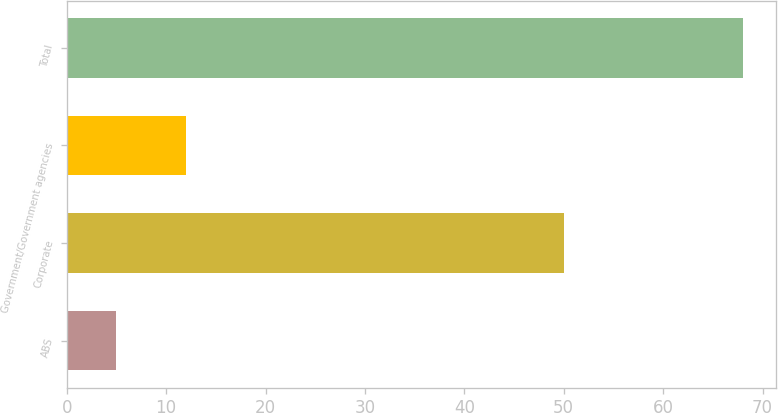Convert chart. <chart><loc_0><loc_0><loc_500><loc_500><bar_chart><fcel>ABS<fcel>Corporate<fcel>Government/Government agencies<fcel>Total<nl><fcel>5<fcel>50<fcel>12<fcel>68<nl></chart> 